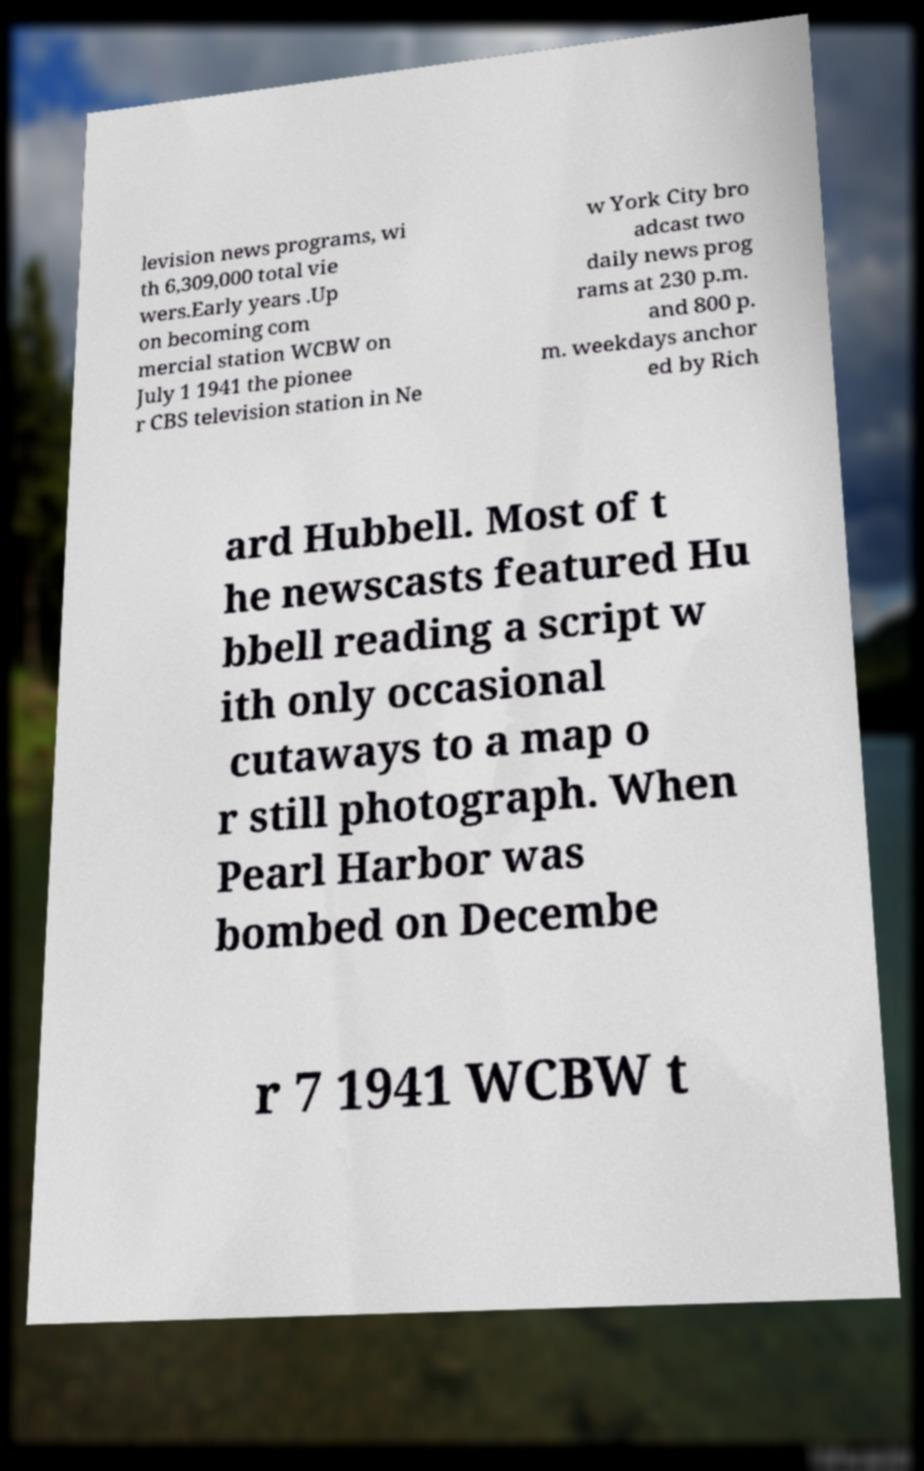What messages or text are displayed in this image? I need them in a readable, typed format. levision news programs, wi th 6,309,000 total vie wers.Early years .Up on becoming com mercial station WCBW on July 1 1941 the pionee r CBS television station in Ne w York City bro adcast two daily news prog rams at 230 p.m. and 800 p. m. weekdays anchor ed by Rich ard Hubbell. Most of t he newscasts featured Hu bbell reading a script w ith only occasional cutaways to a map o r still photograph. When Pearl Harbor was bombed on Decembe r 7 1941 WCBW t 